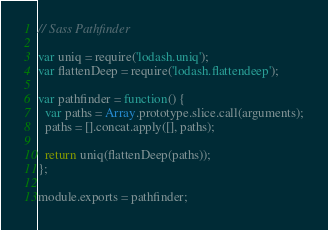Convert code to text. <code><loc_0><loc_0><loc_500><loc_500><_JavaScript_>// Sass Pathfinder

var uniq = require('lodash.uniq');
var flattenDeep = require('lodash.flattendeep');

var pathfinder = function() {
  var paths = Array.prototype.slice.call(arguments);
  paths = [].concat.apply([], paths);

  return uniq(flattenDeep(paths));
};

module.exports = pathfinder;
</code> 